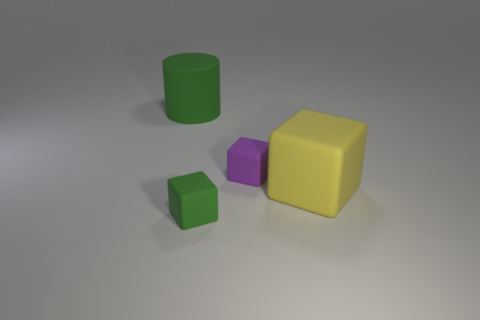Add 4 large red matte things. How many objects exist? 8 Subtract all blocks. How many objects are left? 1 Subtract all small purple objects. Subtract all small purple things. How many objects are left? 2 Add 1 large rubber blocks. How many large rubber blocks are left? 2 Add 4 small brown balls. How many small brown balls exist? 4 Subtract 0 cyan blocks. How many objects are left? 4 